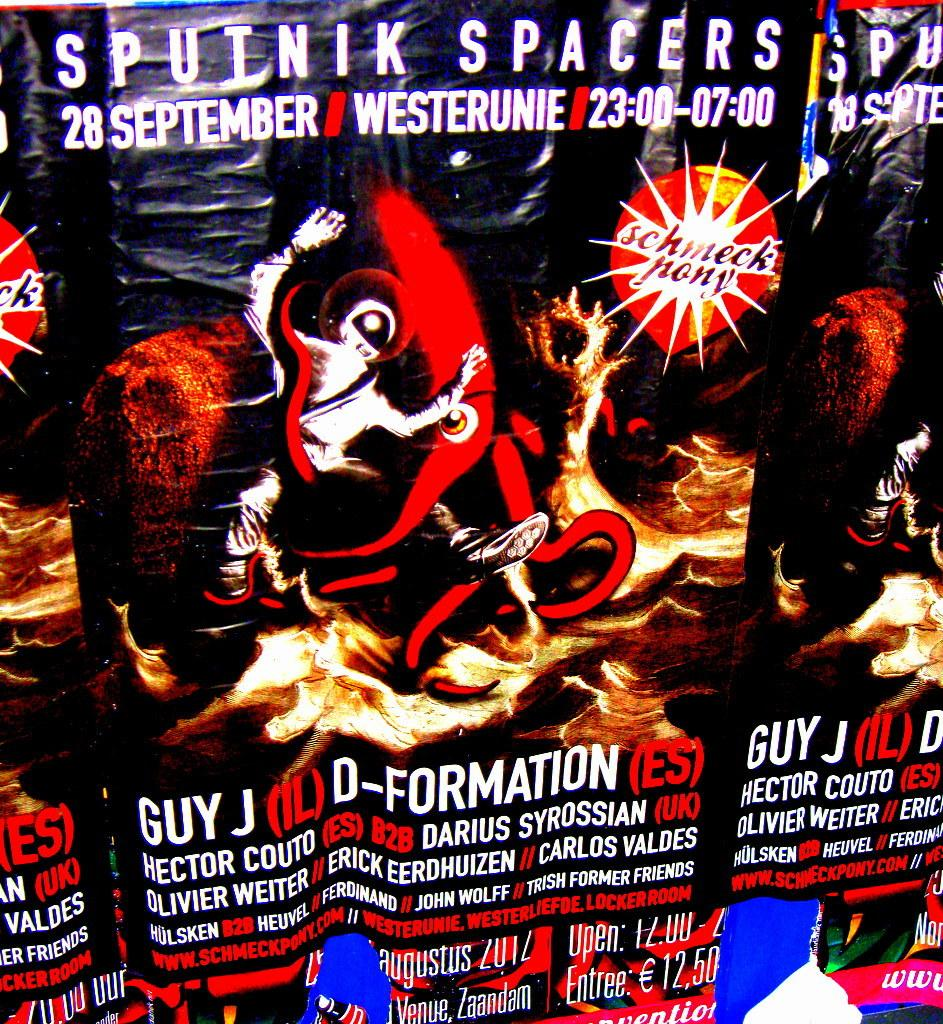<image>
Give a short and clear explanation of the subsequent image. A promotional ad for the Sputnik Spacers on 28 September. 